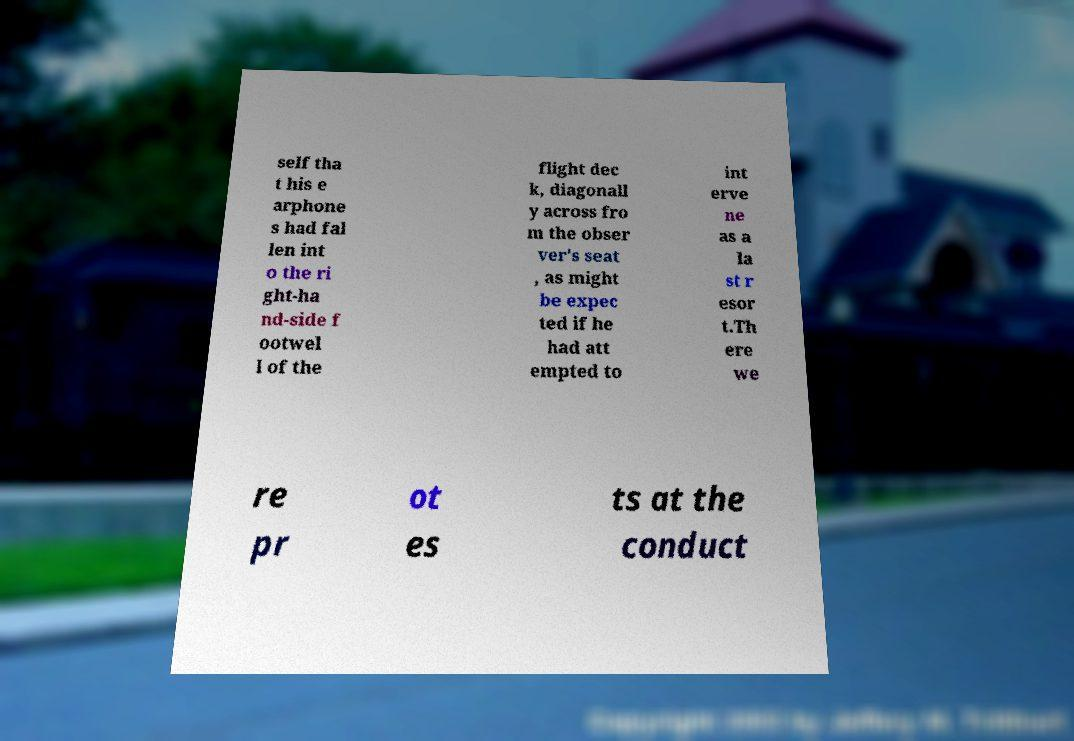Could you extract and type out the text from this image? self tha t his e arphone s had fal len int o the ri ght-ha nd-side f ootwel l of the flight dec k, diagonall y across fro m the obser ver's seat , as might be expec ted if he had att empted to int erve ne as a la st r esor t.Th ere we re pr ot es ts at the conduct 